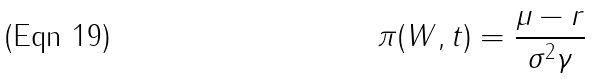<formula> <loc_0><loc_0><loc_500><loc_500>\pi ( W , t ) = \frac { \mu - r } { \sigma ^ { 2 } \gamma }</formula> 